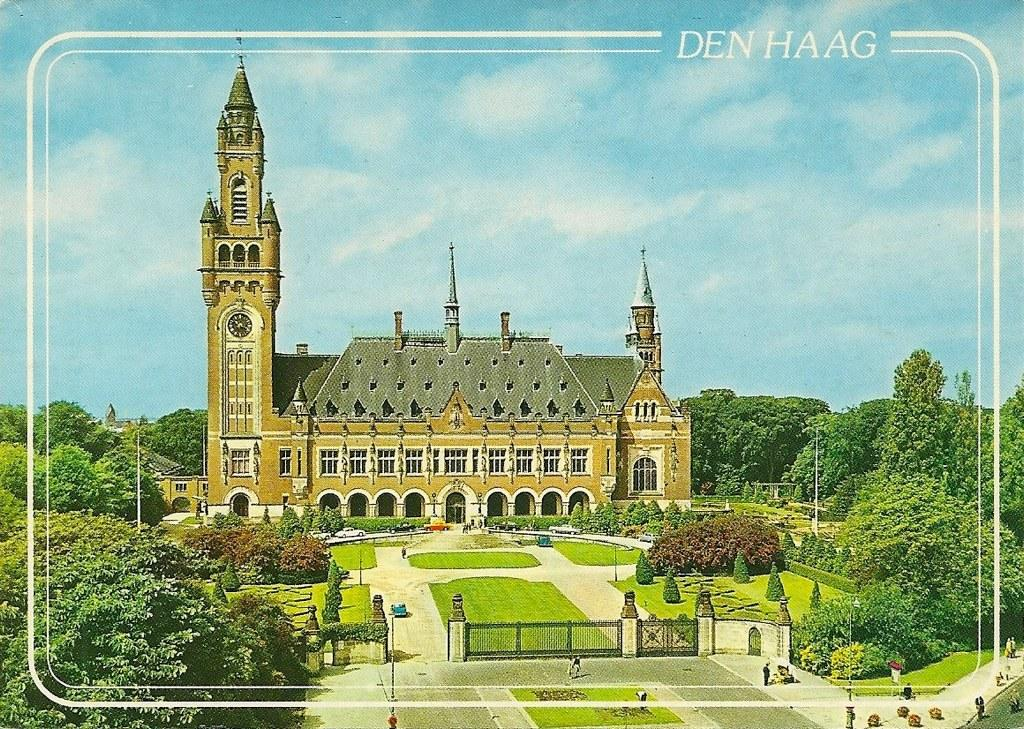What can be seen in the foreground of the poster? In the foreground of the poster, there are trees, poles, a gate, a road, and lawns. What is visible in the background of the poster? In the background of the poster, there are trees, buildings, a path to walk, sky, and clouds. What type of fiction is the governor reading while playing with a ball in the image? There is no fiction, governor, or ball present in the image. 